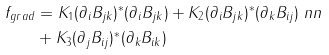<formula> <loc_0><loc_0><loc_500><loc_500>f _ { g r a d } & = K _ { 1 } ( \partial _ { i } B _ { j k } ) ^ { \ast } ( \partial _ { i } B _ { j k } ) + K _ { 2 } ( \partial _ { i } B _ { j k } ) ^ { \ast } ( \partial _ { k } B _ { i j } ) \ n n \\ & + K _ { 3 } ( \partial _ { j } B _ { i j } ) ^ { \ast } ( \partial _ { k } B _ { i k } )</formula> 